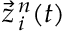Convert formula to latex. <formula><loc_0><loc_0><loc_500><loc_500>\vec { z } _ { \, i } ^ { \, n } ( t )</formula> 